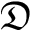Convert formula to latex. <formula><loc_0><loc_0><loc_500><loc_500>\mathfrak { D }</formula> 